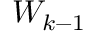Convert formula to latex. <formula><loc_0><loc_0><loc_500><loc_500>W _ { k - 1 }</formula> 